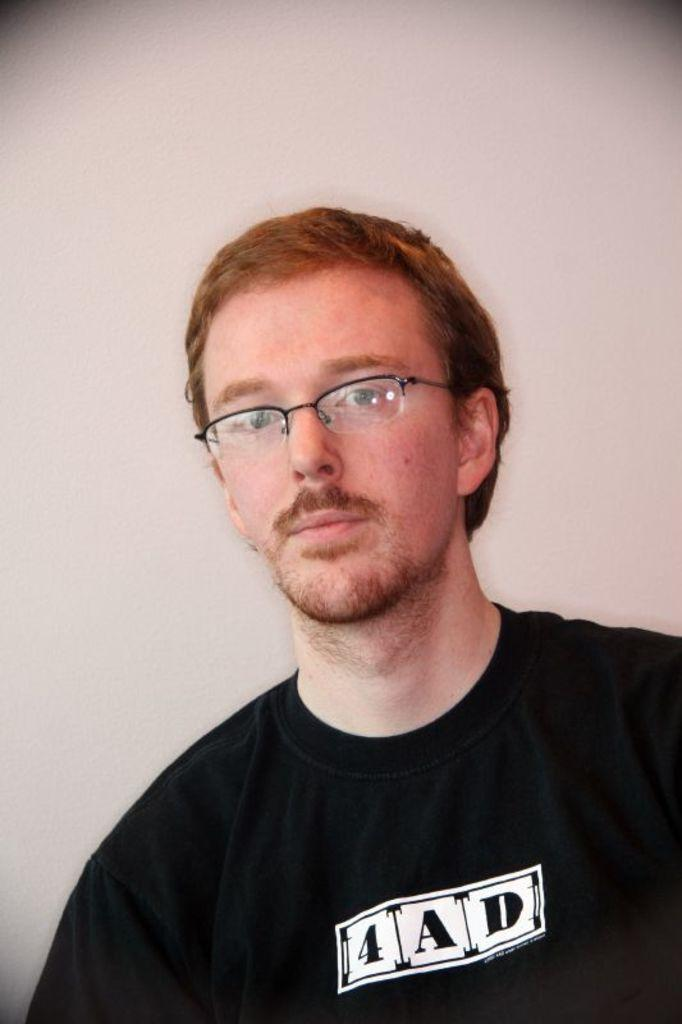What is present in the image? There is a person in the image. What is the person wearing? The person is wearing a black color shirt. What is the color of the background in the image? The background of the image is white. What type of leather is the person sitting on in the image? There is no leather or sitting object present in the image; it only features a person wearing a black color shirt against a white background. What type of wine is the person holding in the image? There is no wine or any object being held present in the image. 